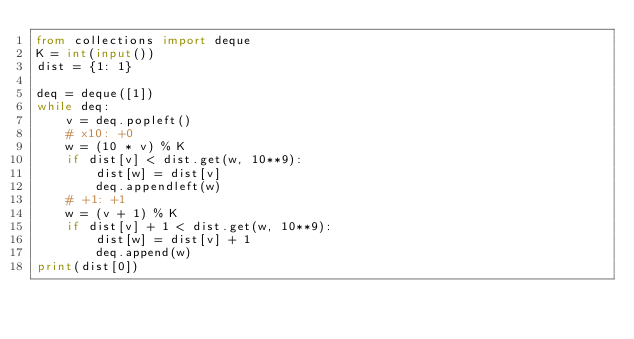Convert code to text. <code><loc_0><loc_0><loc_500><loc_500><_Python_>from collections import deque
K = int(input())
dist = {1: 1}

deq = deque([1])
while deq:
    v = deq.popleft()
    # x10: +0
    w = (10 * v) % K
    if dist[v] < dist.get(w, 10**9):
        dist[w] = dist[v]
        deq.appendleft(w)
    # +1: +1
    w = (v + 1) % K
    if dist[v] + 1 < dist.get(w, 10**9):
        dist[w] = dist[v] + 1
        deq.append(w)
print(dist[0])</code> 